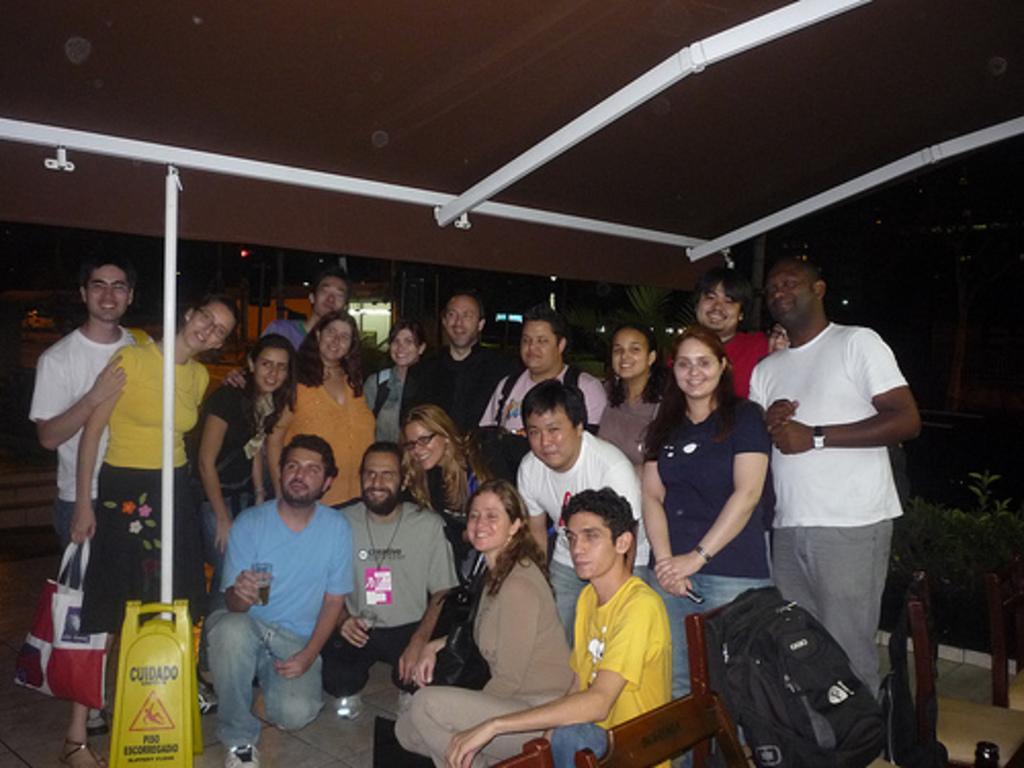Could you give a brief overview of what you see in this image? In this image we can see a group of people standing on the floor. In that a woman is holding a clover and the other is holding a cellphone. We can also see some people sitting on their knees in front of them. In that two men are holding the glasses. On the bottom of the image we can see a signboard on the floor and a bag placed on a chair. On the backside we can see some plants, lights and a roof with some poles. 